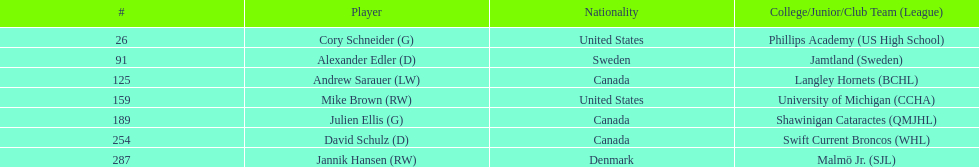List only the american players. Cory Schneider (G), Mike Brown (RW). 